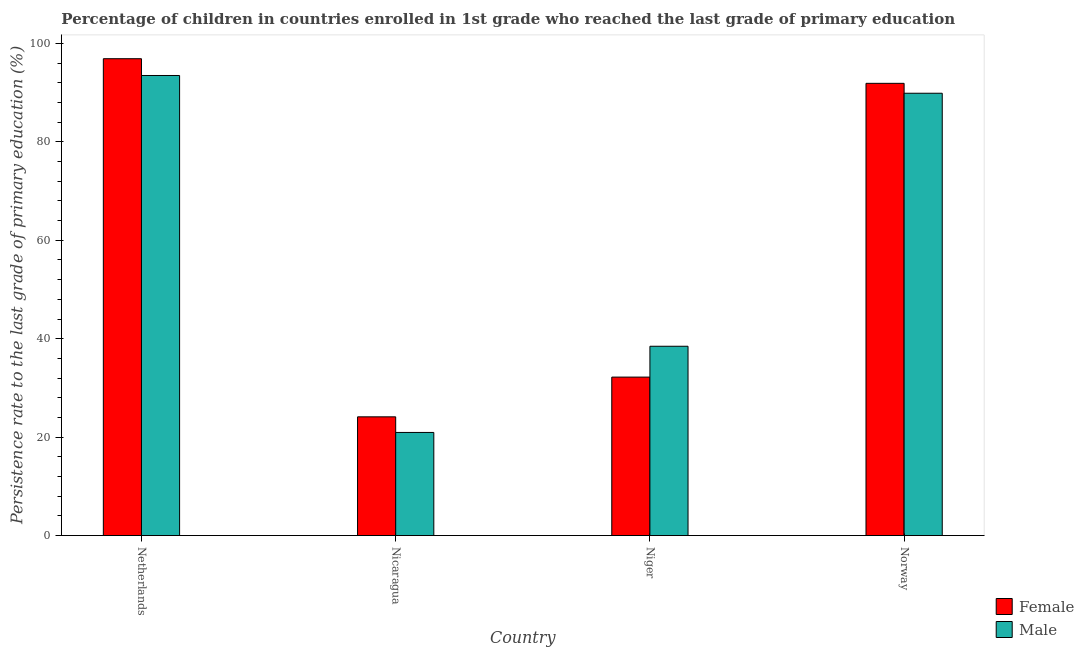How many different coloured bars are there?
Offer a very short reply. 2. How many groups of bars are there?
Offer a very short reply. 4. Are the number of bars per tick equal to the number of legend labels?
Your response must be concise. Yes. How many bars are there on the 1st tick from the left?
Provide a succinct answer. 2. How many bars are there on the 2nd tick from the right?
Offer a terse response. 2. In how many cases, is the number of bars for a given country not equal to the number of legend labels?
Ensure brevity in your answer.  0. What is the persistence rate of male students in Norway?
Your response must be concise. 89.89. Across all countries, what is the maximum persistence rate of male students?
Give a very brief answer. 93.49. Across all countries, what is the minimum persistence rate of male students?
Provide a succinct answer. 20.95. In which country was the persistence rate of female students maximum?
Offer a very short reply. Netherlands. In which country was the persistence rate of female students minimum?
Your response must be concise. Nicaragua. What is the total persistence rate of male students in the graph?
Give a very brief answer. 242.81. What is the difference between the persistence rate of female students in Netherlands and that in Norway?
Provide a succinct answer. 5. What is the difference between the persistence rate of male students in Niger and the persistence rate of female students in Netherlands?
Your response must be concise. -58.43. What is the average persistence rate of female students per country?
Offer a very short reply. 61.28. What is the difference between the persistence rate of female students and persistence rate of male students in Niger?
Your response must be concise. -6.27. What is the ratio of the persistence rate of female students in Netherlands to that in Niger?
Offer a very short reply. 3.01. Is the persistence rate of male students in Netherlands less than that in Nicaragua?
Make the answer very short. No. Is the difference between the persistence rate of male students in Nicaragua and Norway greater than the difference between the persistence rate of female students in Nicaragua and Norway?
Make the answer very short. No. What is the difference between the highest and the second highest persistence rate of male students?
Provide a succinct answer. 3.61. What is the difference between the highest and the lowest persistence rate of female students?
Offer a terse response. 72.77. What does the 2nd bar from the left in Netherlands represents?
Provide a short and direct response. Male. How many bars are there?
Offer a very short reply. 8. Are all the bars in the graph horizontal?
Your answer should be compact. No. Does the graph contain any zero values?
Offer a terse response. No. Does the graph contain grids?
Offer a very short reply. No. How many legend labels are there?
Keep it short and to the point. 2. What is the title of the graph?
Your answer should be compact. Percentage of children in countries enrolled in 1st grade who reached the last grade of primary education. Does "Frequency of shipment arrival" appear as one of the legend labels in the graph?
Provide a succinct answer. No. What is the label or title of the X-axis?
Offer a terse response. Country. What is the label or title of the Y-axis?
Keep it short and to the point. Persistence rate to the last grade of primary education (%). What is the Persistence rate to the last grade of primary education (%) of Female in Netherlands?
Provide a succinct answer. 96.9. What is the Persistence rate to the last grade of primary education (%) of Male in Netherlands?
Make the answer very short. 93.49. What is the Persistence rate to the last grade of primary education (%) in Female in Nicaragua?
Make the answer very short. 24.13. What is the Persistence rate to the last grade of primary education (%) in Male in Nicaragua?
Give a very brief answer. 20.95. What is the Persistence rate to the last grade of primary education (%) of Female in Niger?
Your answer should be compact. 32.2. What is the Persistence rate to the last grade of primary education (%) in Male in Niger?
Offer a terse response. 38.47. What is the Persistence rate to the last grade of primary education (%) in Female in Norway?
Ensure brevity in your answer.  91.9. What is the Persistence rate to the last grade of primary education (%) in Male in Norway?
Make the answer very short. 89.89. Across all countries, what is the maximum Persistence rate to the last grade of primary education (%) in Female?
Ensure brevity in your answer.  96.9. Across all countries, what is the maximum Persistence rate to the last grade of primary education (%) of Male?
Give a very brief answer. 93.49. Across all countries, what is the minimum Persistence rate to the last grade of primary education (%) of Female?
Your response must be concise. 24.13. Across all countries, what is the minimum Persistence rate to the last grade of primary education (%) in Male?
Ensure brevity in your answer.  20.95. What is the total Persistence rate to the last grade of primary education (%) in Female in the graph?
Offer a terse response. 245.13. What is the total Persistence rate to the last grade of primary education (%) of Male in the graph?
Offer a terse response. 242.81. What is the difference between the Persistence rate to the last grade of primary education (%) of Female in Netherlands and that in Nicaragua?
Your answer should be compact. 72.77. What is the difference between the Persistence rate to the last grade of primary education (%) in Male in Netherlands and that in Nicaragua?
Provide a succinct answer. 72.54. What is the difference between the Persistence rate to the last grade of primary education (%) in Female in Netherlands and that in Niger?
Ensure brevity in your answer.  64.7. What is the difference between the Persistence rate to the last grade of primary education (%) in Male in Netherlands and that in Niger?
Make the answer very short. 55.02. What is the difference between the Persistence rate to the last grade of primary education (%) in Female in Netherlands and that in Norway?
Provide a succinct answer. 5. What is the difference between the Persistence rate to the last grade of primary education (%) of Male in Netherlands and that in Norway?
Make the answer very short. 3.61. What is the difference between the Persistence rate to the last grade of primary education (%) in Female in Nicaragua and that in Niger?
Your answer should be compact. -8.07. What is the difference between the Persistence rate to the last grade of primary education (%) in Male in Nicaragua and that in Niger?
Provide a succinct answer. -17.52. What is the difference between the Persistence rate to the last grade of primary education (%) of Female in Nicaragua and that in Norway?
Provide a short and direct response. -67.77. What is the difference between the Persistence rate to the last grade of primary education (%) in Male in Nicaragua and that in Norway?
Make the answer very short. -68.93. What is the difference between the Persistence rate to the last grade of primary education (%) in Female in Niger and that in Norway?
Offer a terse response. -59.7. What is the difference between the Persistence rate to the last grade of primary education (%) of Male in Niger and that in Norway?
Provide a succinct answer. -51.42. What is the difference between the Persistence rate to the last grade of primary education (%) of Female in Netherlands and the Persistence rate to the last grade of primary education (%) of Male in Nicaragua?
Your answer should be compact. 75.95. What is the difference between the Persistence rate to the last grade of primary education (%) of Female in Netherlands and the Persistence rate to the last grade of primary education (%) of Male in Niger?
Make the answer very short. 58.43. What is the difference between the Persistence rate to the last grade of primary education (%) of Female in Netherlands and the Persistence rate to the last grade of primary education (%) of Male in Norway?
Provide a succinct answer. 7.01. What is the difference between the Persistence rate to the last grade of primary education (%) of Female in Nicaragua and the Persistence rate to the last grade of primary education (%) of Male in Niger?
Make the answer very short. -14.34. What is the difference between the Persistence rate to the last grade of primary education (%) of Female in Nicaragua and the Persistence rate to the last grade of primary education (%) of Male in Norway?
Your answer should be very brief. -65.76. What is the difference between the Persistence rate to the last grade of primary education (%) in Female in Niger and the Persistence rate to the last grade of primary education (%) in Male in Norway?
Give a very brief answer. -57.69. What is the average Persistence rate to the last grade of primary education (%) of Female per country?
Make the answer very short. 61.28. What is the average Persistence rate to the last grade of primary education (%) of Male per country?
Ensure brevity in your answer.  60.7. What is the difference between the Persistence rate to the last grade of primary education (%) of Female and Persistence rate to the last grade of primary education (%) of Male in Netherlands?
Your answer should be compact. 3.41. What is the difference between the Persistence rate to the last grade of primary education (%) of Female and Persistence rate to the last grade of primary education (%) of Male in Nicaragua?
Your answer should be compact. 3.17. What is the difference between the Persistence rate to the last grade of primary education (%) of Female and Persistence rate to the last grade of primary education (%) of Male in Niger?
Offer a very short reply. -6.27. What is the difference between the Persistence rate to the last grade of primary education (%) of Female and Persistence rate to the last grade of primary education (%) of Male in Norway?
Keep it short and to the point. 2.01. What is the ratio of the Persistence rate to the last grade of primary education (%) of Female in Netherlands to that in Nicaragua?
Your answer should be compact. 4.02. What is the ratio of the Persistence rate to the last grade of primary education (%) in Male in Netherlands to that in Nicaragua?
Provide a short and direct response. 4.46. What is the ratio of the Persistence rate to the last grade of primary education (%) of Female in Netherlands to that in Niger?
Provide a succinct answer. 3.01. What is the ratio of the Persistence rate to the last grade of primary education (%) in Male in Netherlands to that in Niger?
Provide a short and direct response. 2.43. What is the ratio of the Persistence rate to the last grade of primary education (%) of Female in Netherlands to that in Norway?
Your answer should be compact. 1.05. What is the ratio of the Persistence rate to the last grade of primary education (%) of Male in Netherlands to that in Norway?
Your answer should be very brief. 1.04. What is the ratio of the Persistence rate to the last grade of primary education (%) in Female in Nicaragua to that in Niger?
Keep it short and to the point. 0.75. What is the ratio of the Persistence rate to the last grade of primary education (%) in Male in Nicaragua to that in Niger?
Ensure brevity in your answer.  0.54. What is the ratio of the Persistence rate to the last grade of primary education (%) of Female in Nicaragua to that in Norway?
Provide a succinct answer. 0.26. What is the ratio of the Persistence rate to the last grade of primary education (%) in Male in Nicaragua to that in Norway?
Your response must be concise. 0.23. What is the ratio of the Persistence rate to the last grade of primary education (%) in Female in Niger to that in Norway?
Your answer should be compact. 0.35. What is the ratio of the Persistence rate to the last grade of primary education (%) in Male in Niger to that in Norway?
Keep it short and to the point. 0.43. What is the difference between the highest and the second highest Persistence rate to the last grade of primary education (%) in Female?
Provide a short and direct response. 5. What is the difference between the highest and the second highest Persistence rate to the last grade of primary education (%) of Male?
Ensure brevity in your answer.  3.61. What is the difference between the highest and the lowest Persistence rate to the last grade of primary education (%) in Female?
Ensure brevity in your answer.  72.77. What is the difference between the highest and the lowest Persistence rate to the last grade of primary education (%) in Male?
Provide a succinct answer. 72.54. 